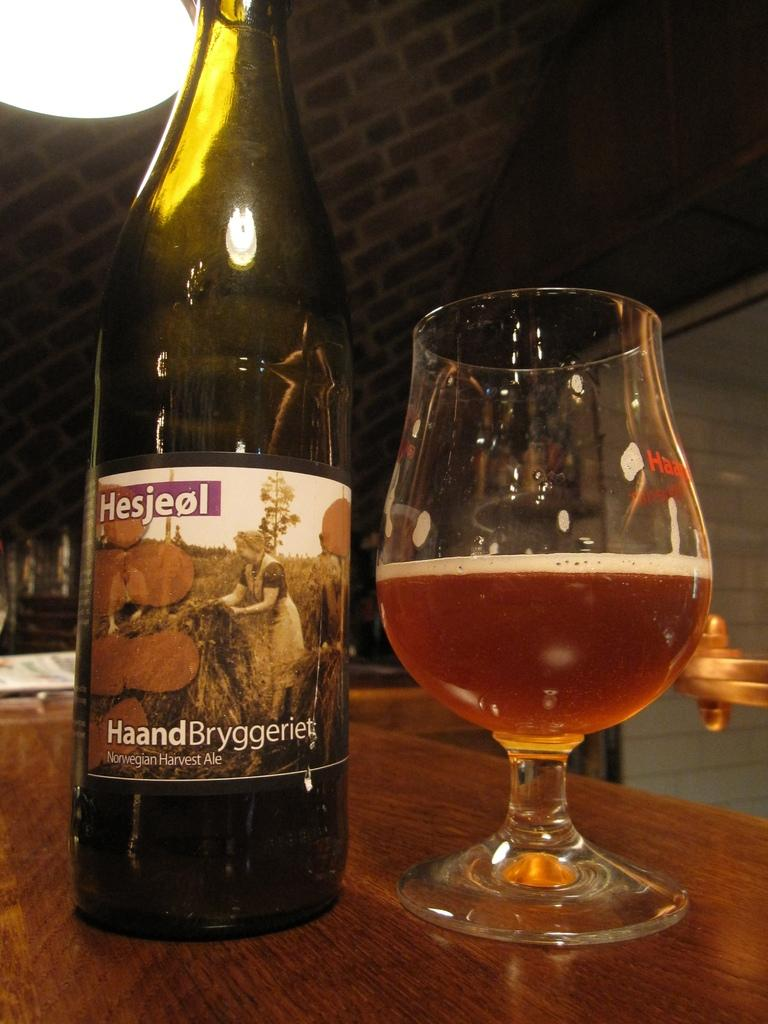<image>
Summarize the visual content of the image. A bottle of Norwegian Harvest Ale next to a glass of the same thing. 